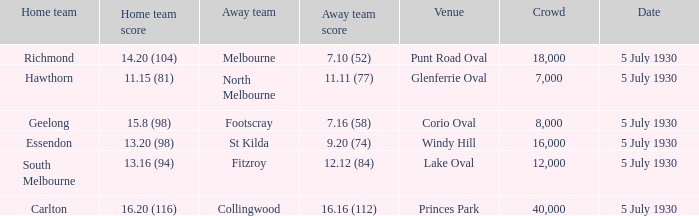Who is the away side at corio oval? Footscray. 